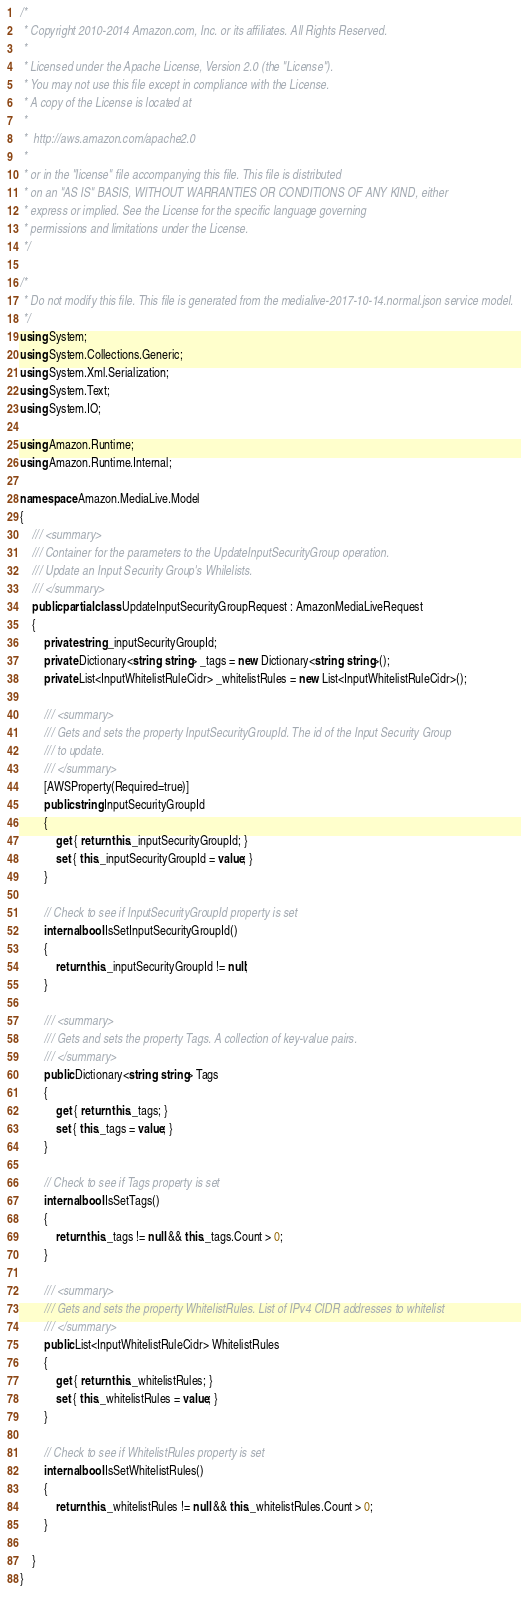<code> <loc_0><loc_0><loc_500><loc_500><_C#_>/*
 * Copyright 2010-2014 Amazon.com, Inc. or its affiliates. All Rights Reserved.
 * 
 * Licensed under the Apache License, Version 2.0 (the "License").
 * You may not use this file except in compliance with the License.
 * A copy of the License is located at
 * 
 *  http://aws.amazon.com/apache2.0
 * 
 * or in the "license" file accompanying this file. This file is distributed
 * on an "AS IS" BASIS, WITHOUT WARRANTIES OR CONDITIONS OF ANY KIND, either
 * express or implied. See the License for the specific language governing
 * permissions and limitations under the License.
 */

/*
 * Do not modify this file. This file is generated from the medialive-2017-10-14.normal.json service model.
 */
using System;
using System.Collections.Generic;
using System.Xml.Serialization;
using System.Text;
using System.IO;

using Amazon.Runtime;
using Amazon.Runtime.Internal;

namespace Amazon.MediaLive.Model
{
    /// <summary>
    /// Container for the parameters to the UpdateInputSecurityGroup operation.
    /// Update an Input Security Group's Whilelists.
    /// </summary>
    public partial class UpdateInputSecurityGroupRequest : AmazonMediaLiveRequest
    {
        private string _inputSecurityGroupId;
        private Dictionary<string, string> _tags = new Dictionary<string, string>();
        private List<InputWhitelistRuleCidr> _whitelistRules = new List<InputWhitelistRuleCidr>();

        /// <summary>
        /// Gets and sets the property InputSecurityGroupId. The id of the Input Security Group
        /// to update.
        /// </summary>
        [AWSProperty(Required=true)]
        public string InputSecurityGroupId
        {
            get { return this._inputSecurityGroupId; }
            set { this._inputSecurityGroupId = value; }
        }

        // Check to see if InputSecurityGroupId property is set
        internal bool IsSetInputSecurityGroupId()
        {
            return this._inputSecurityGroupId != null;
        }

        /// <summary>
        /// Gets and sets the property Tags. A collection of key-value pairs.
        /// </summary>
        public Dictionary<string, string> Tags
        {
            get { return this._tags; }
            set { this._tags = value; }
        }

        // Check to see if Tags property is set
        internal bool IsSetTags()
        {
            return this._tags != null && this._tags.Count > 0; 
        }

        /// <summary>
        /// Gets and sets the property WhitelistRules. List of IPv4 CIDR addresses to whitelist
        /// </summary>
        public List<InputWhitelistRuleCidr> WhitelistRules
        {
            get { return this._whitelistRules; }
            set { this._whitelistRules = value; }
        }

        // Check to see if WhitelistRules property is set
        internal bool IsSetWhitelistRules()
        {
            return this._whitelistRules != null && this._whitelistRules.Count > 0; 
        }

    }
}</code> 